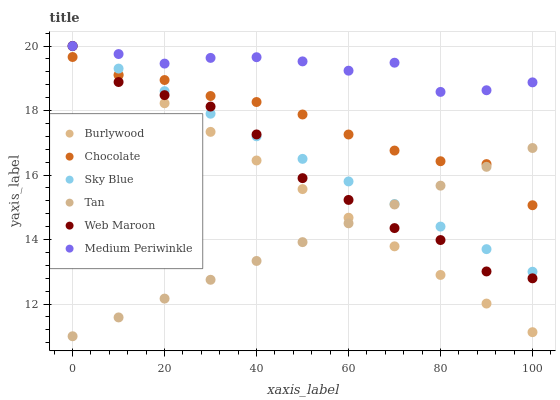Does Tan have the minimum area under the curve?
Answer yes or no. Yes. Does Medium Periwinkle have the maximum area under the curve?
Answer yes or no. Yes. Does Web Maroon have the minimum area under the curve?
Answer yes or no. No. Does Web Maroon have the maximum area under the curve?
Answer yes or no. No. Is Sky Blue the smoothest?
Answer yes or no. Yes. Is Web Maroon the roughest?
Answer yes or no. Yes. Is Medium Periwinkle the smoothest?
Answer yes or no. No. Is Medium Periwinkle the roughest?
Answer yes or no. No. Does Tan have the lowest value?
Answer yes or no. Yes. Does Web Maroon have the lowest value?
Answer yes or no. No. Does Sky Blue have the highest value?
Answer yes or no. Yes. Does Chocolate have the highest value?
Answer yes or no. No. Is Chocolate less than Medium Periwinkle?
Answer yes or no. Yes. Is Medium Periwinkle greater than Tan?
Answer yes or no. Yes. Does Web Maroon intersect Sky Blue?
Answer yes or no. Yes. Is Web Maroon less than Sky Blue?
Answer yes or no. No. Is Web Maroon greater than Sky Blue?
Answer yes or no. No. Does Chocolate intersect Medium Periwinkle?
Answer yes or no. No. 